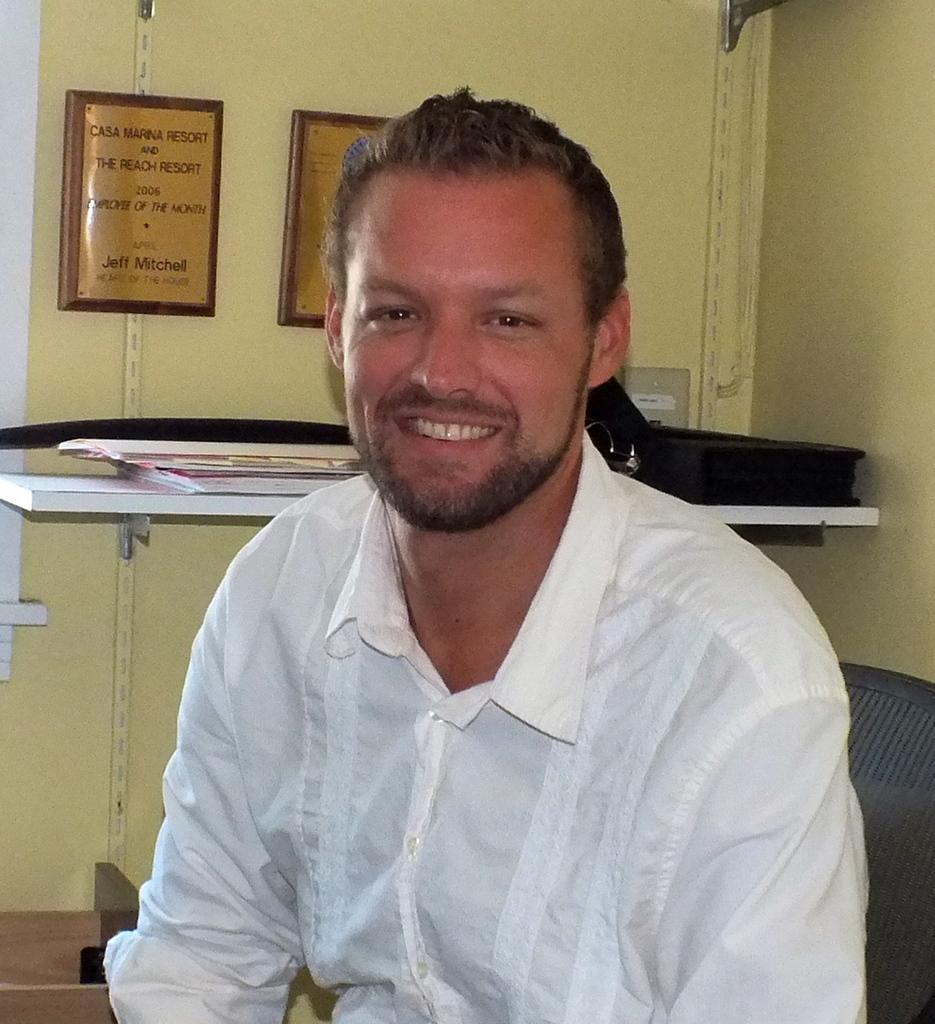Could you give a brief overview of what you see in this image? In this image we can see a person sitting on the chair, there are few objects on the shelf and frames with text on the wall. 